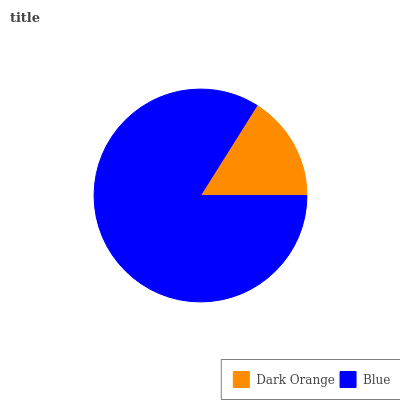Is Dark Orange the minimum?
Answer yes or no. Yes. Is Blue the maximum?
Answer yes or no. Yes. Is Blue the minimum?
Answer yes or no. No. Is Blue greater than Dark Orange?
Answer yes or no. Yes. Is Dark Orange less than Blue?
Answer yes or no. Yes. Is Dark Orange greater than Blue?
Answer yes or no. No. Is Blue less than Dark Orange?
Answer yes or no. No. Is Blue the high median?
Answer yes or no. Yes. Is Dark Orange the low median?
Answer yes or no. Yes. Is Dark Orange the high median?
Answer yes or no. No. Is Blue the low median?
Answer yes or no. No. 